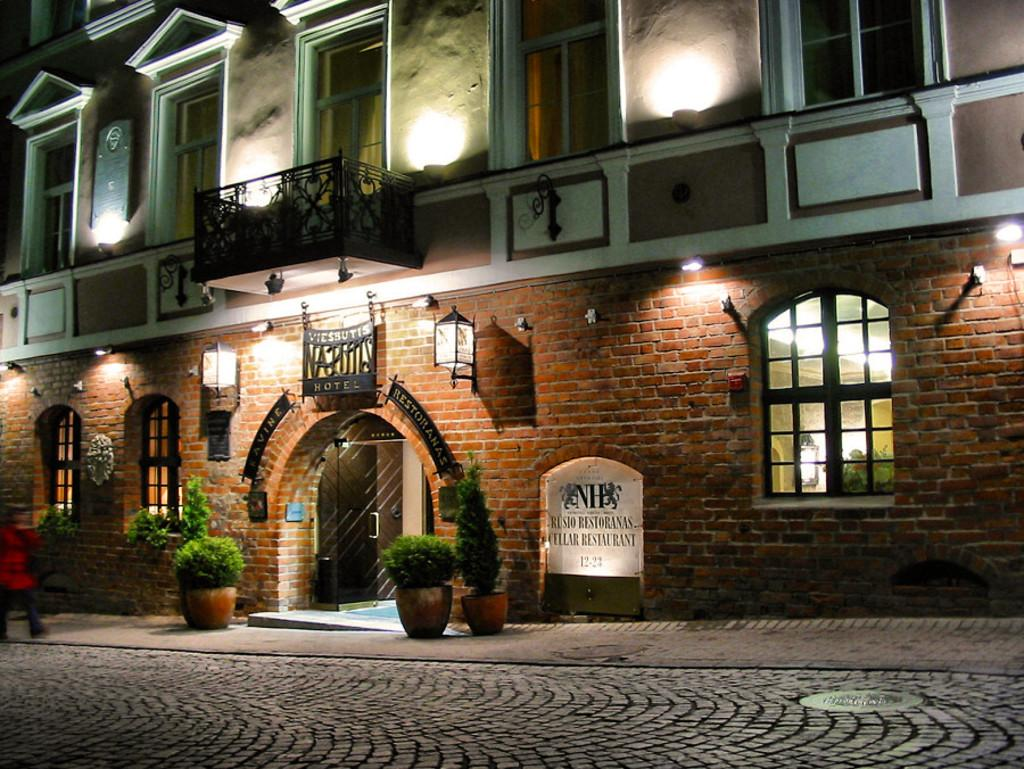<image>
Write a terse but informative summary of the picture. The beautiful building shown has a cellar restaurant within its establishment. 